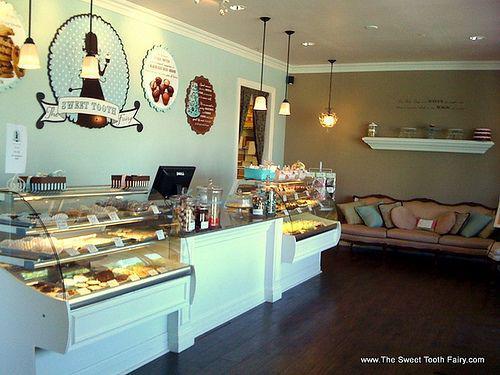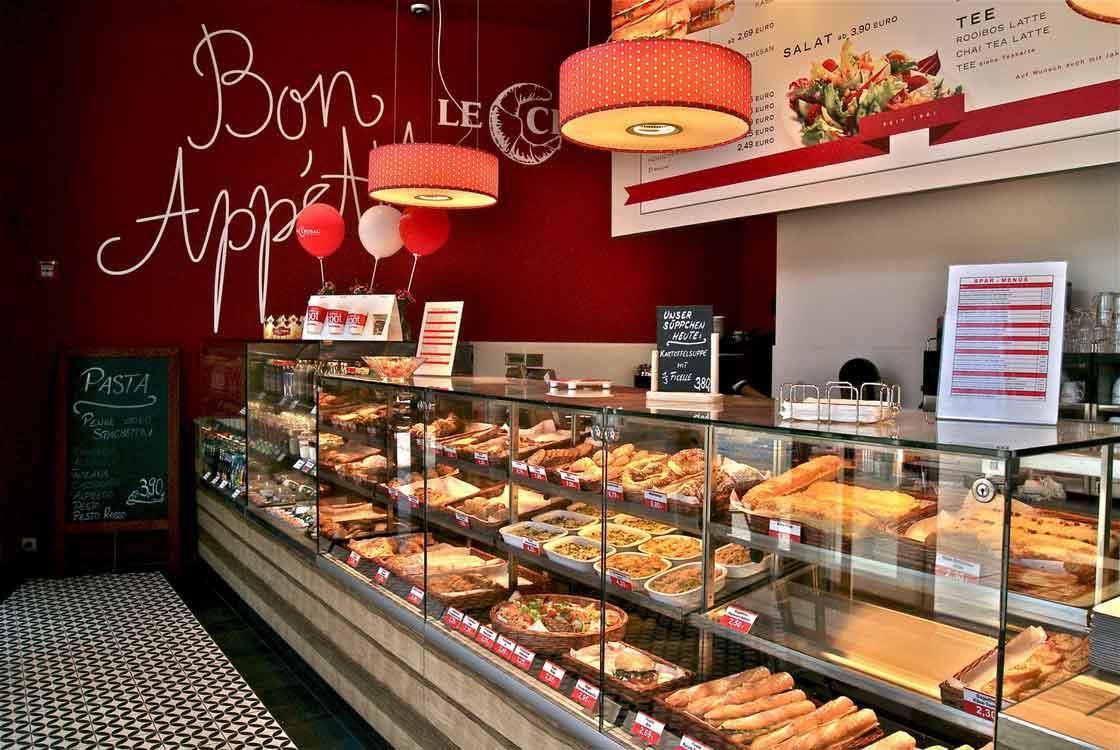The first image is the image on the left, the second image is the image on the right. For the images shown, is this caption "One image shows a food establishment with a geometric pattern, black and white floor." true? Answer yes or no. Yes. The first image is the image on the left, the second image is the image on the right. Evaluate the accuracy of this statement regarding the images: "there are chairs in the image on the right.". Is it true? Answer yes or no. No. 